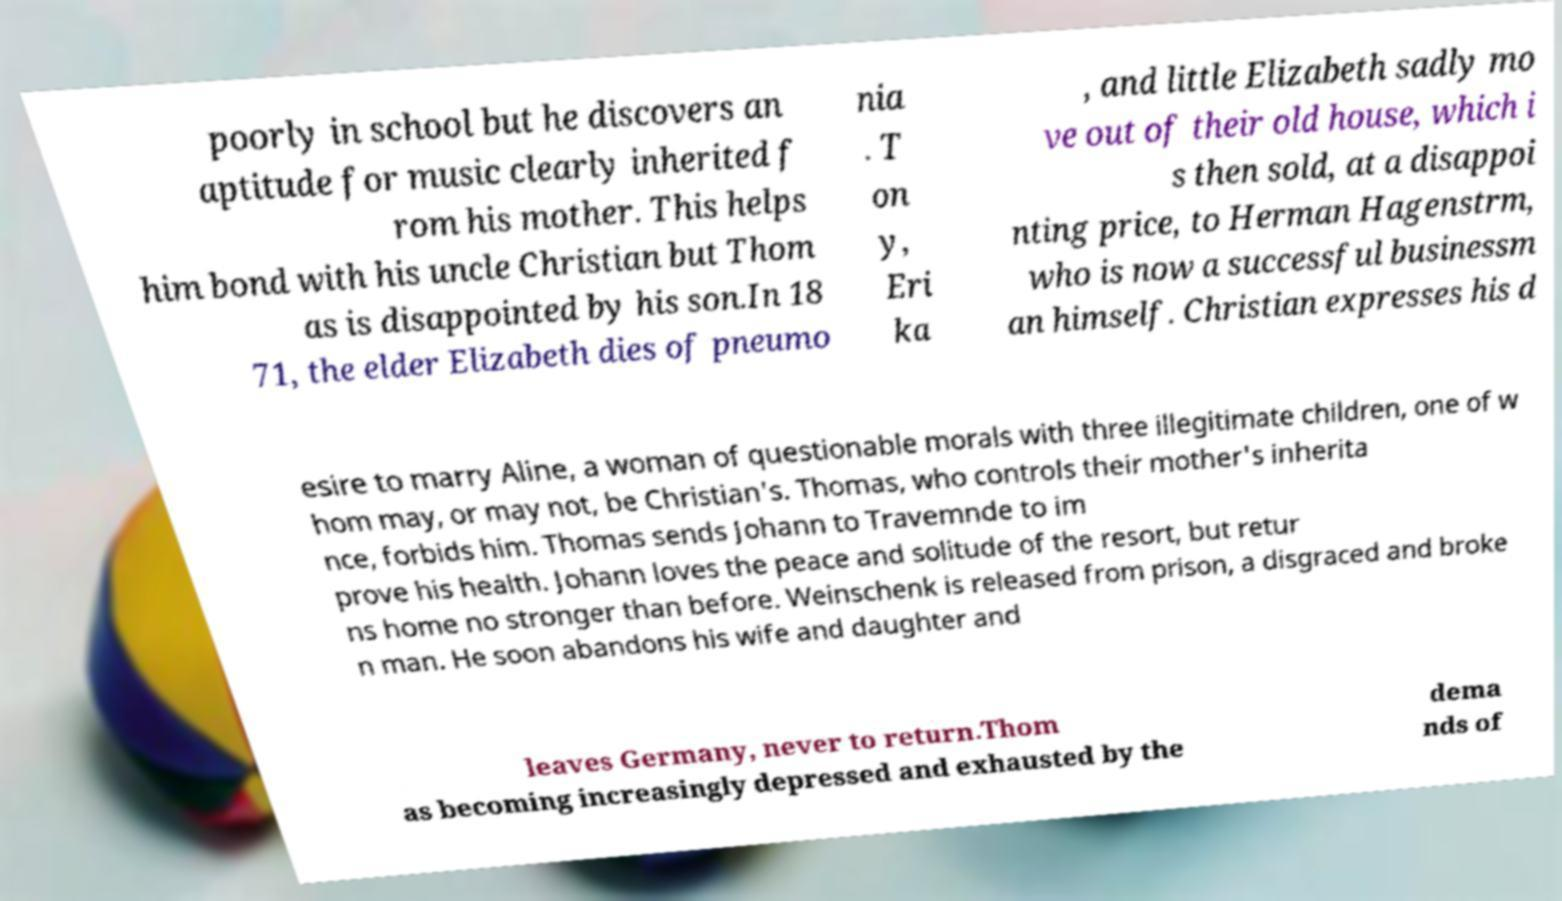I need the written content from this picture converted into text. Can you do that? poorly in school but he discovers an aptitude for music clearly inherited f rom his mother. This helps him bond with his uncle Christian but Thom as is disappointed by his son.In 18 71, the elder Elizabeth dies of pneumo nia . T on y, Eri ka , and little Elizabeth sadly mo ve out of their old house, which i s then sold, at a disappoi nting price, to Herman Hagenstrm, who is now a successful businessm an himself. Christian expresses his d esire to marry Aline, a woman of questionable morals with three illegitimate children, one of w hom may, or may not, be Christian's. Thomas, who controls their mother's inherita nce, forbids him. Thomas sends Johann to Travemnde to im prove his health. Johann loves the peace and solitude of the resort, but retur ns home no stronger than before. Weinschenk is released from prison, a disgraced and broke n man. He soon abandons his wife and daughter and leaves Germany, never to return.Thom as becoming increasingly depressed and exhausted by the dema nds of 